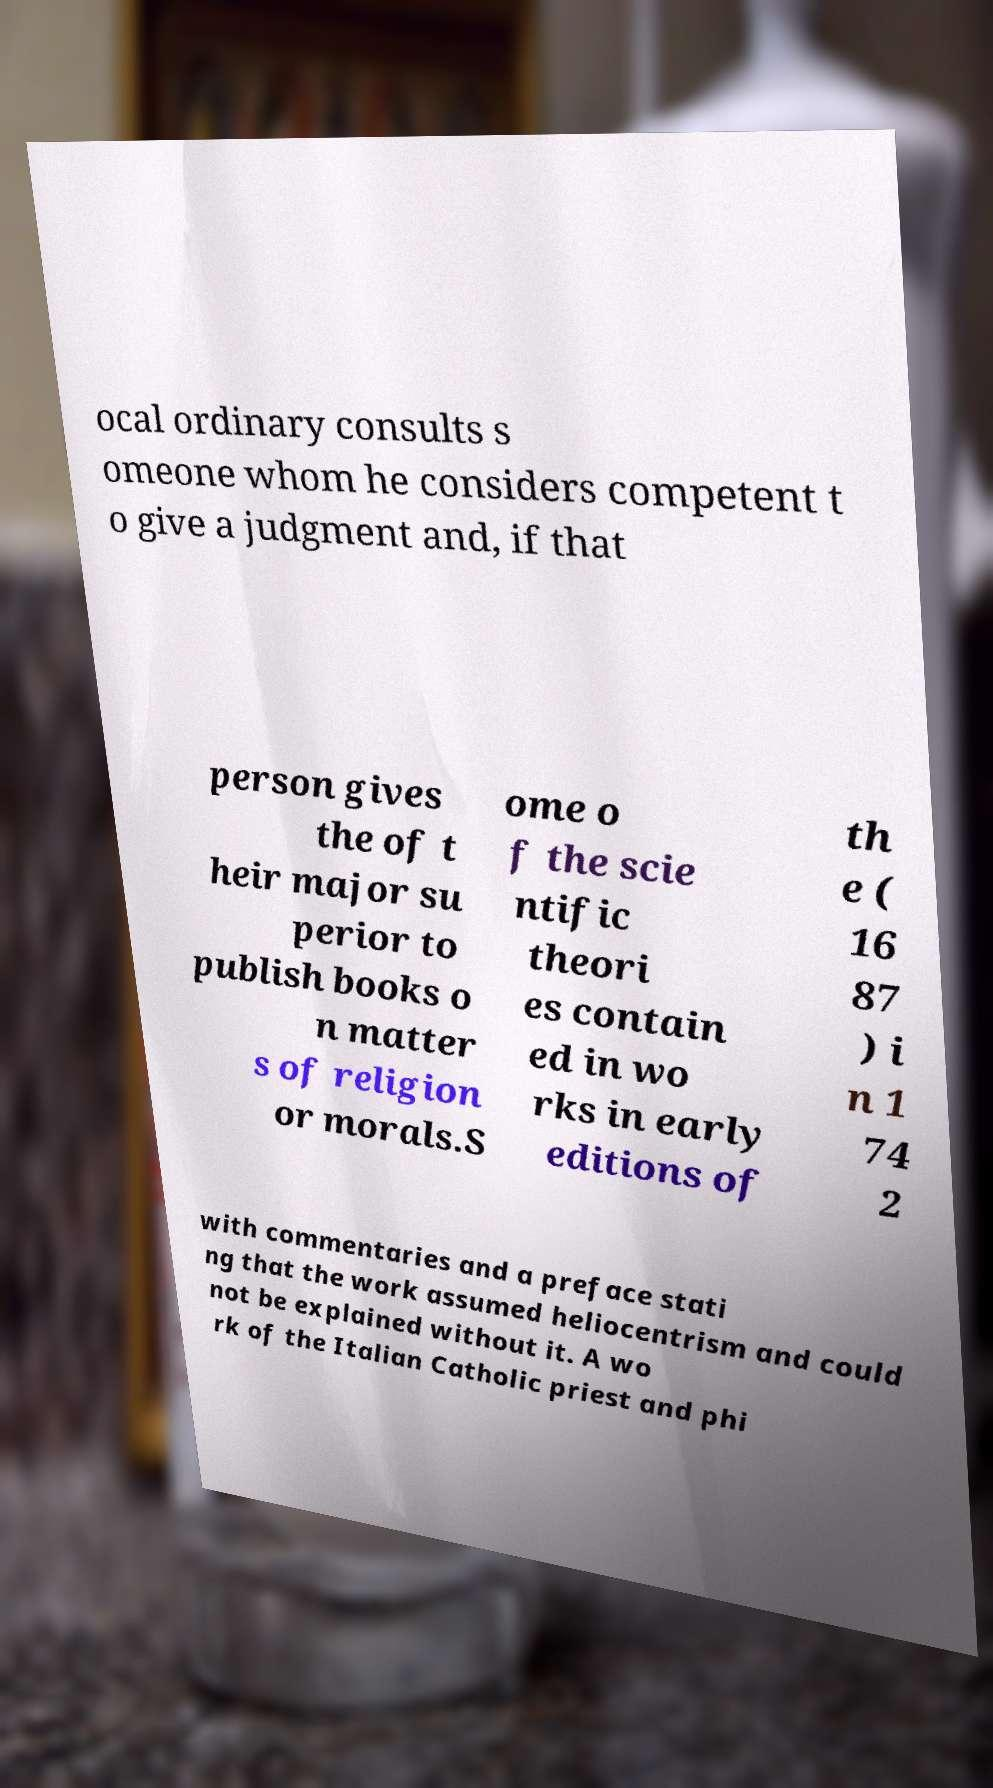Could you assist in decoding the text presented in this image and type it out clearly? ocal ordinary consults s omeone whom he considers competent t o give a judgment and, if that person gives the of t heir major su perior to publish books o n matter s of religion or morals.S ome o f the scie ntific theori es contain ed in wo rks in early editions of th e ( 16 87 ) i n 1 74 2 with commentaries and a preface stati ng that the work assumed heliocentrism and could not be explained without it. A wo rk of the Italian Catholic priest and phi 